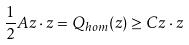Convert formula to latex. <formula><loc_0><loc_0><loc_500><loc_500>\frac { 1 } { 2 } A { z } \cdot { z } = Q _ { h o m } ( { z } ) \geq C { z } \cdot { z }</formula> 